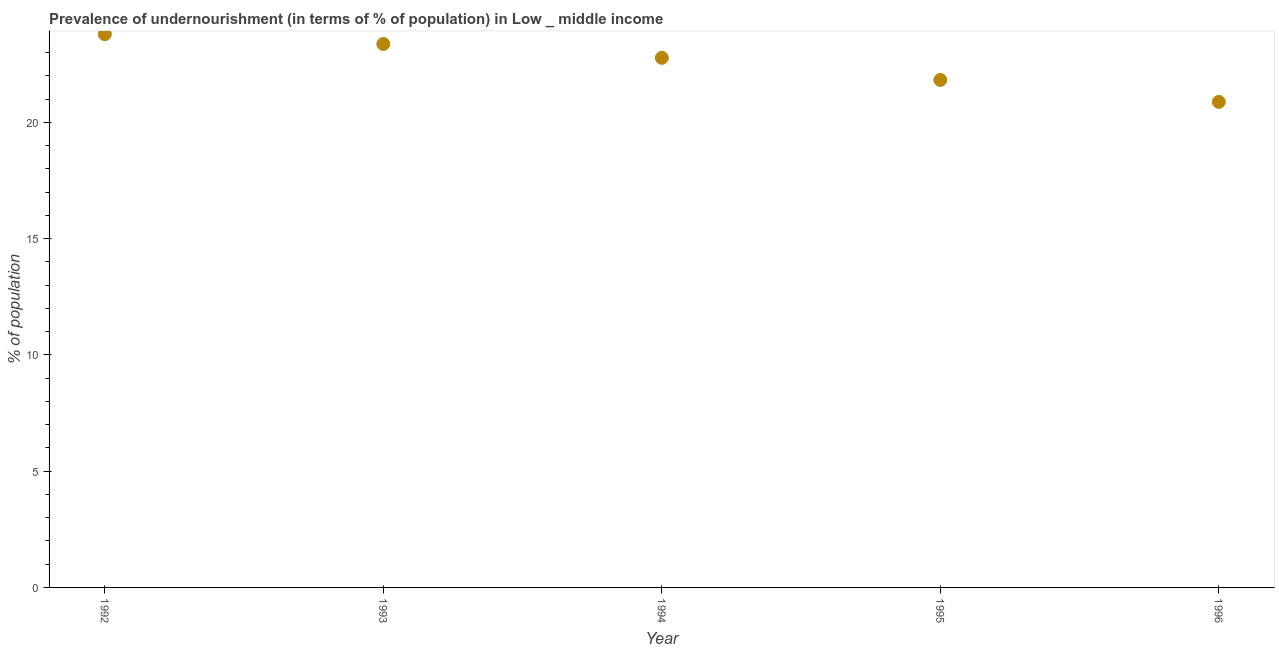What is the percentage of undernourished population in 1995?
Provide a short and direct response. 21.82. Across all years, what is the maximum percentage of undernourished population?
Your answer should be compact. 23.79. Across all years, what is the minimum percentage of undernourished population?
Offer a terse response. 20.88. In which year was the percentage of undernourished population maximum?
Make the answer very short. 1992. What is the sum of the percentage of undernourished population?
Offer a very short reply. 112.63. What is the difference between the percentage of undernourished population in 1992 and 1994?
Your answer should be very brief. 1.02. What is the average percentage of undernourished population per year?
Your answer should be very brief. 22.53. What is the median percentage of undernourished population?
Ensure brevity in your answer.  22.77. In how many years, is the percentage of undernourished population greater than 7 %?
Your answer should be compact. 5. Do a majority of the years between 1992 and 1993 (inclusive) have percentage of undernourished population greater than 6 %?
Give a very brief answer. Yes. What is the ratio of the percentage of undernourished population in 1992 to that in 1993?
Offer a very short reply. 1.02. Is the percentage of undernourished population in 1994 less than that in 1996?
Your answer should be compact. No. Is the difference between the percentage of undernourished population in 1994 and 1996 greater than the difference between any two years?
Offer a very short reply. No. What is the difference between the highest and the second highest percentage of undernourished population?
Keep it short and to the point. 0.42. Is the sum of the percentage of undernourished population in 1995 and 1996 greater than the maximum percentage of undernourished population across all years?
Provide a short and direct response. Yes. What is the difference between the highest and the lowest percentage of undernourished population?
Offer a terse response. 2.91. In how many years, is the percentage of undernourished population greater than the average percentage of undernourished population taken over all years?
Your response must be concise. 3. How many years are there in the graph?
Your answer should be compact. 5. What is the title of the graph?
Your answer should be compact. Prevalence of undernourishment (in terms of % of population) in Low _ middle income. What is the label or title of the Y-axis?
Keep it short and to the point. % of population. What is the % of population in 1992?
Make the answer very short. 23.79. What is the % of population in 1993?
Keep it short and to the point. 23.37. What is the % of population in 1994?
Ensure brevity in your answer.  22.77. What is the % of population in 1995?
Offer a terse response. 21.82. What is the % of population in 1996?
Offer a very short reply. 20.88. What is the difference between the % of population in 1992 and 1993?
Offer a terse response. 0.42. What is the difference between the % of population in 1992 and 1994?
Offer a terse response. 1.02. What is the difference between the % of population in 1992 and 1995?
Your response must be concise. 1.97. What is the difference between the % of population in 1992 and 1996?
Give a very brief answer. 2.91. What is the difference between the % of population in 1993 and 1994?
Offer a terse response. 0.6. What is the difference between the % of population in 1993 and 1995?
Give a very brief answer. 1.55. What is the difference between the % of population in 1993 and 1996?
Ensure brevity in your answer.  2.49. What is the difference between the % of population in 1994 and 1995?
Make the answer very short. 0.95. What is the difference between the % of population in 1994 and 1996?
Make the answer very short. 1.89. What is the difference between the % of population in 1995 and 1996?
Provide a succinct answer. 0.94. What is the ratio of the % of population in 1992 to that in 1994?
Provide a succinct answer. 1.04. What is the ratio of the % of population in 1992 to that in 1995?
Give a very brief answer. 1.09. What is the ratio of the % of population in 1992 to that in 1996?
Provide a short and direct response. 1.14. What is the ratio of the % of population in 1993 to that in 1994?
Your response must be concise. 1.03. What is the ratio of the % of population in 1993 to that in 1995?
Make the answer very short. 1.07. What is the ratio of the % of population in 1993 to that in 1996?
Keep it short and to the point. 1.12. What is the ratio of the % of population in 1994 to that in 1995?
Provide a short and direct response. 1.04. What is the ratio of the % of population in 1994 to that in 1996?
Your answer should be compact. 1.09. What is the ratio of the % of population in 1995 to that in 1996?
Your response must be concise. 1.04. 